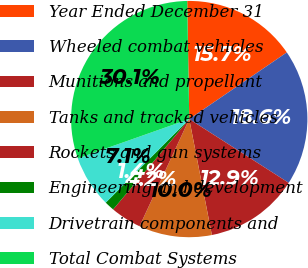Convert chart. <chart><loc_0><loc_0><loc_500><loc_500><pie_chart><fcel>Year Ended December 31<fcel>Wheeled combat vehicles<fcel>Munitions and propellant<fcel>Tanks and tracked vehicles<fcel>Rockets and gun systems<fcel>Engineering and development<fcel>Drivetrain components and<fcel>Total Combat Systems<nl><fcel>15.74%<fcel>18.61%<fcel>12.86%<fcel>9.98%<fcel>4.23%<fcel>1.35%<fcel>7.11%<fcel>30.12%<nl></chart> 